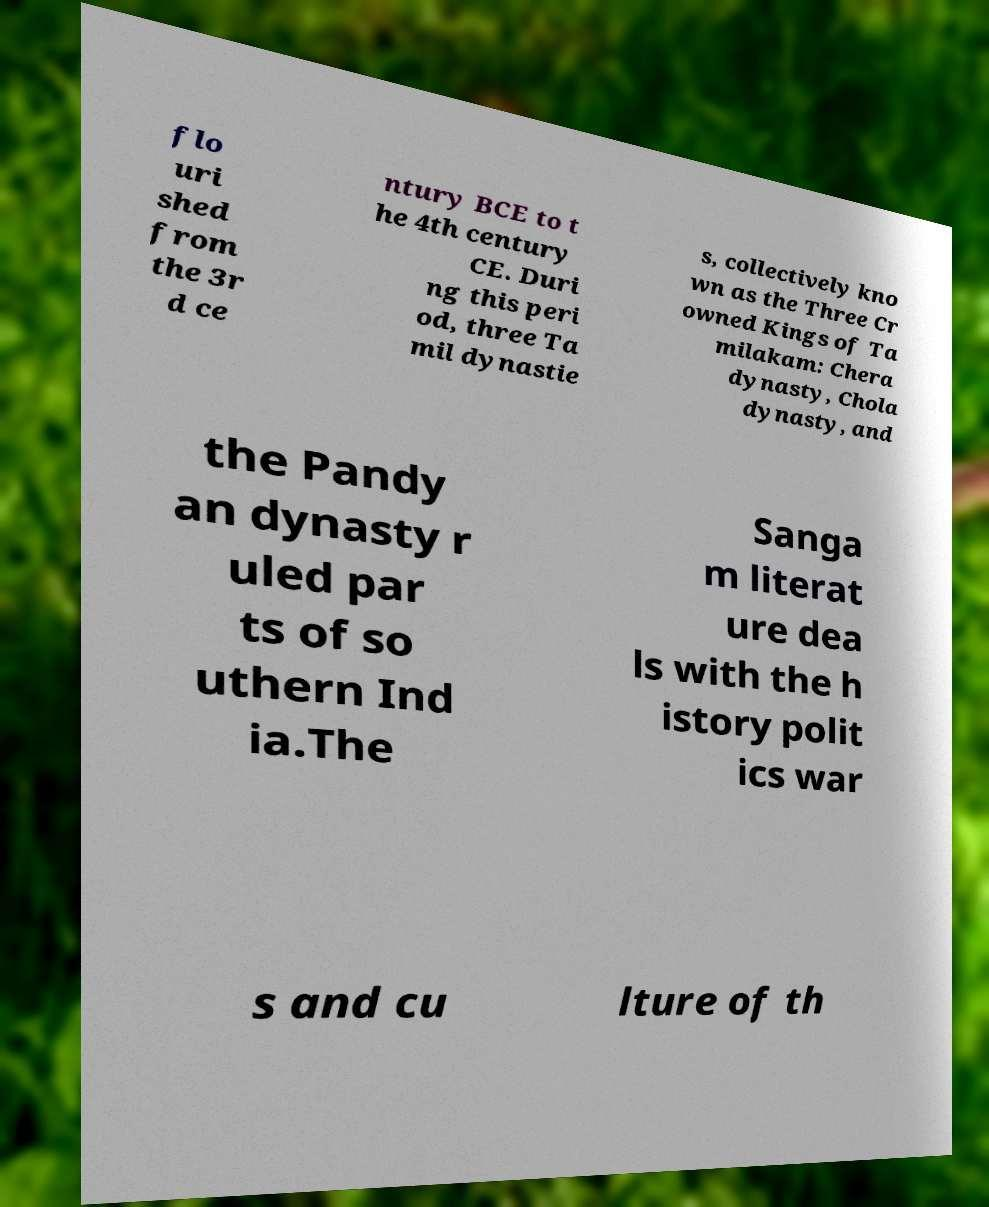I need the written content from this picture converted into text. Can you do that? flo uri shed from the 3r d ce ntury BCE to t he 4th century CE. Duri ng this peri od, three Ta mil dynastie s, collectively kno wn as the Three Cr owned Kings of Ta milakam: Chera dynasty, Chola dynasty, and the Pandy an dynasty r uled par ts of so uthern Ind ia.The Sanga m literat ure dea ls with the h istory polit ics war s and cu lture of th 